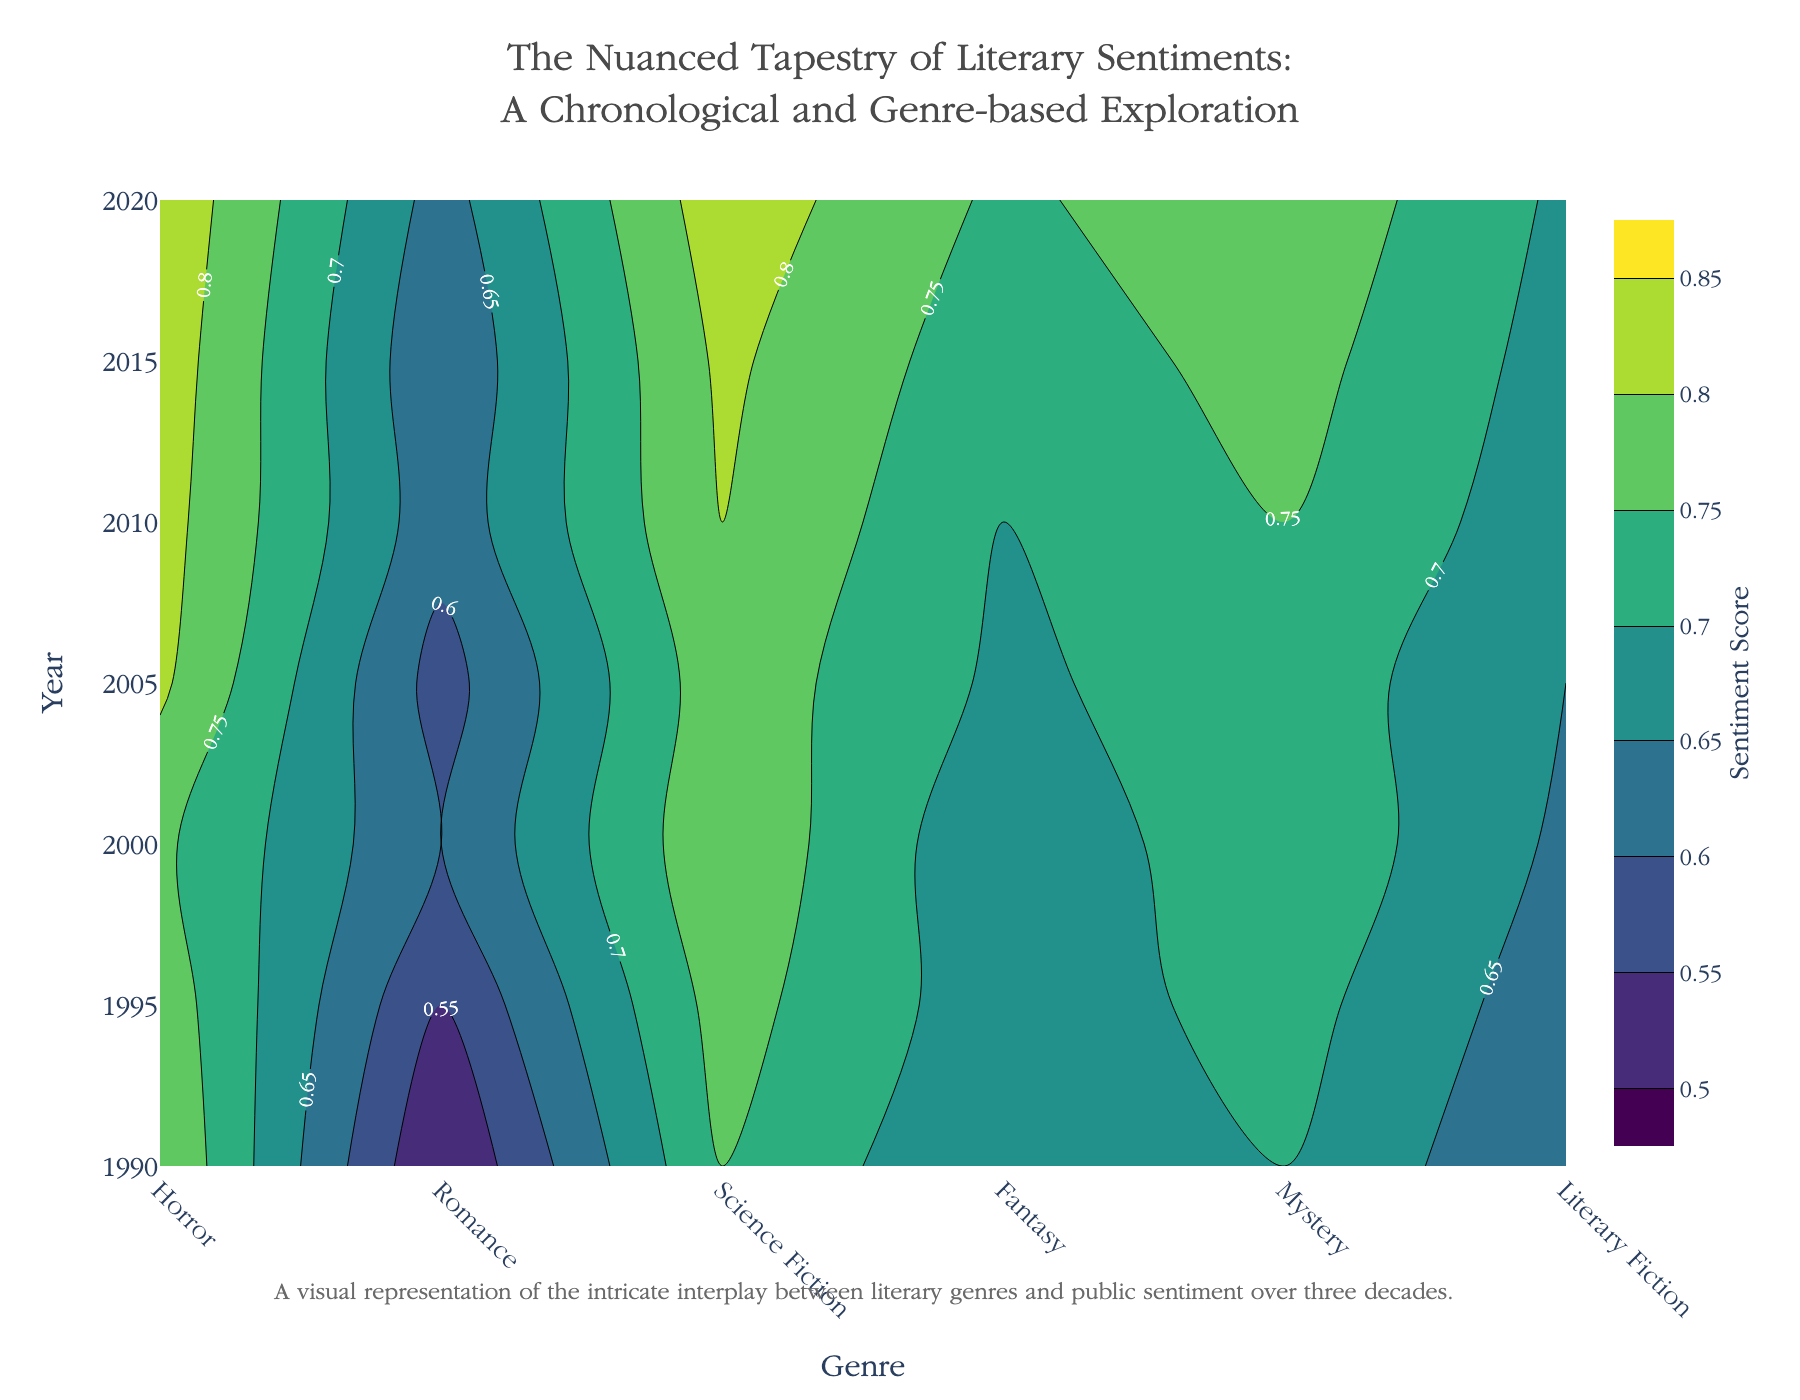What is the title of the figure? The title is displayed prominently at the top of the figure and provides an overview of what the plot represents: "The Nuanced Tapestry of Literary Sentiments: A Chronological and Genre-based Exploration".
Answer: The Nuanced Tapestry of Literary Sentiments: A Chronological and Genre-based Exploration What genre has the highest average sentiment score in 2020? By examining the contour lines and labels in the 2020 column, the genre with the peak value in 2020 can be identified. Fantasy has the highest sentiment score in 2020.
Answer: Fantasy Which years are represented in the plot? The years are marked on the y-axis of the plot. They range from 1990 to 2020 in increments of 5 years.
Answer: 1990, 1995, 2000, 2005, 2010, 2015, 2020 How does the Romance genre's sentiment score change over time? Observing the contour lines in the Romance column and noting the labels for each year shows a steady increase in sentiment score from 0.7 in 1990 to 0.79 in 2020.
Answer: It increases Which genre showed the most significant improvement in sentiment score from 1990 to 2020? To determine the genre with the greatest increase, compare the sentiment scores for all genres in 1990 and 2020. Fantasy increased from 0.8 in 1990 to 0.84 in 2020.
Answer: Fantasy In 2015, which genre had a sentiment score of approximately 0.77? By looking at the contour labels corresponding to the year 2015, Romance had a sentiment score around 0.77.
Answer: Romance What can be inferred about the trend of sentiment scores in Horror from 1990 to 2020? By tracing the contour labels in the Horror column from 1990 to 2020, we see that it fluctuates slightly (0.5 in 1990, 0.55 in 1995, 0.6 in 2000, 0.58 in 2005, 0.62 in 2010, 0.61 in 2015, 0.63 in 2020).
Answer: It generally increases with minor fluctuations Which genres experienced a peak sentiment score in 2005? By examining the contour labels for 2005, Fantasy experienced a peak sentiment score of 0.81.
Answer: Fantasy What is the range of sentiment scores for Literary Fiction from 1990 to 2020? Reviewing the contour labels for Literary Fiction across the years shows scores ranging from 0.75 in 1990 to 0.83 in 2020.
Answer: 0.75 to 0.83 